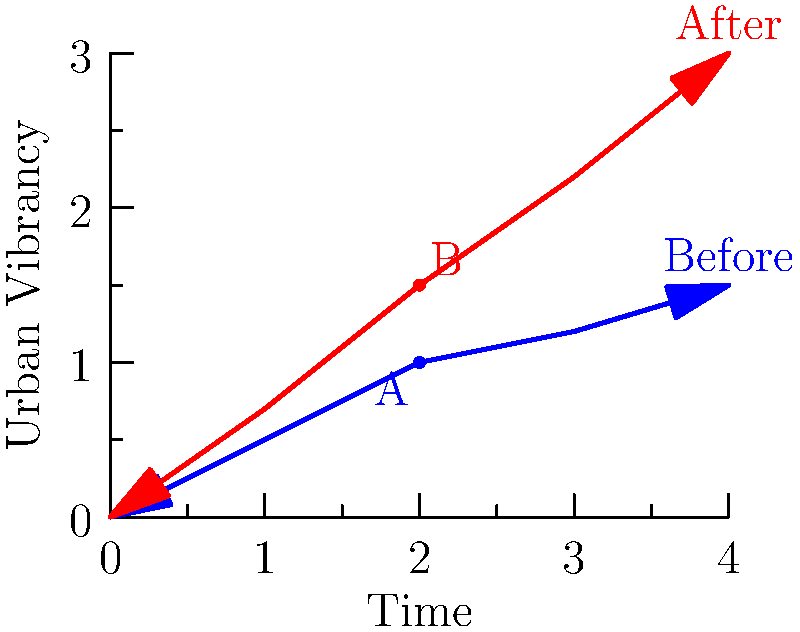In the graph above, which represents the change in urban vibrancy over time before and after the introduction of street performers, what is the approximate percentage increase in urban vibrancy at point B compared to point A? To calculate the percentage increase in urban vibrancy from point A to point B:

1. Identify the y-values:
   Point A (before street performers): y ≈ 1
   Point B (after street performers): y ≈ 1.5

2. Calculate the difference:
   Increase = 1.5 - 1 = 0.5

3. Calculate the percentage increase:
   Percentage increase = (Increase / Original Value) × 100
   = (0.5 / 1) × 100
   = 0.5 × 100
   = 50%

Therefore, the approximate percentage increase in urban vibrancy at point B compared to point A is 50%.
Answer: 50% 